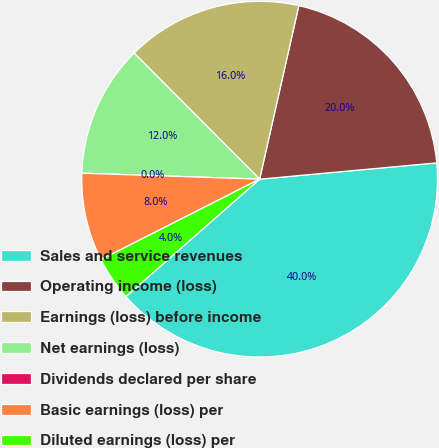Convert chart to OTSL. <chart><loc_0><loc_0><loc_500><loc_500><pie_chart><fcel>Sales and service revenues<fcel>Operating income (loss)<fcel>Earnings (loss) before income<fcel>Net earnings (loss)<fcel>Dividends declared per share<fcel>Basic earnings (loss) per<fcel>Diluted earnings (loss) per<nl><fcel>39.99%<fcel>20.0%<fcel>16.0%<fcel>12.0%<fcel>0.0%<fcel>8.0%<fcel>4.0%<nl></chart> 